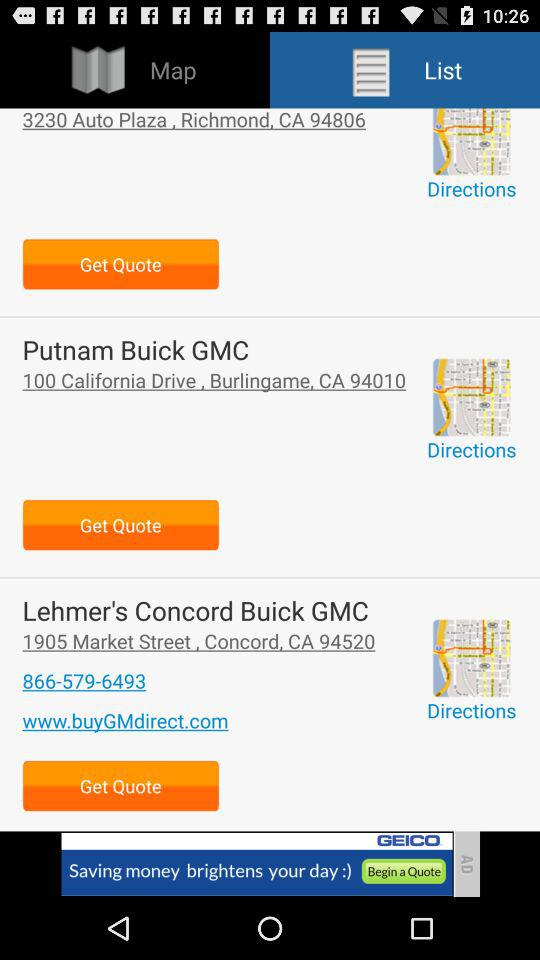What is the website of "Lehmer's Concord Buick GMC"? The website of "Lehmer's Concord Buick GMC" is www.buyGMdirect.com. 